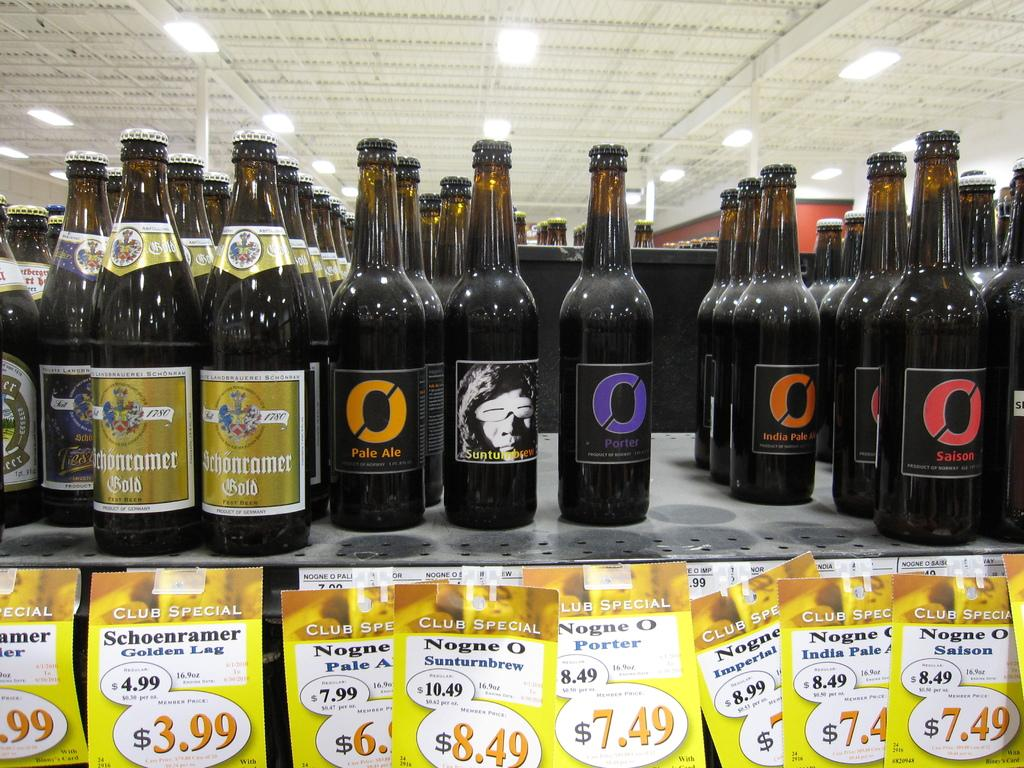<image>
Relay a brief, clear account of the picture shown. A bottle of Pale Ale sitting on a shelf with many other bottles. 